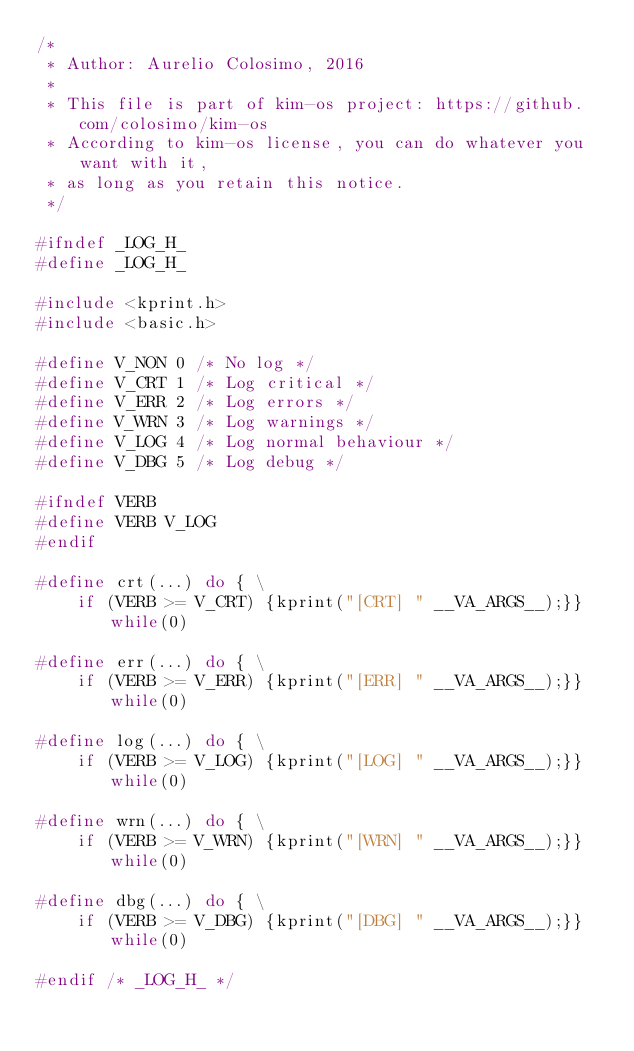<code> <loc_0><loc_0><loc_500><loc_500><_C_>/*
 * Author: Aurelio Colosimo, 2016
 *
 * This file is part of kim-os project: https://github.com/colosimo/kim-os
 * According to kim-os license, you can do whatever you want with it,
 * as long as you retain this notice.
 */

#ifndef _LOG_H_
#define _LOG_H_

#include <kprint.h>
#include <basic.h>

#define V_NON 0 /* No log */
#define V_CRT 1 /* Log critical */
#define V_ERR 2 /* Log errors */
#define V_WRN 3 /* Log warnings */
#define V_LOG 4 /* Log normal behaviour */
#define V_DBG 5 /* Log debug */

#ifndef VERB
#define VERB V_LOG
#endif

#define crt(...) do { \
	if (VERB >= V_CRT) {kprint("[CRT] " __VA_ARGS__);}} while(0)

#define err(...) do { \
	if (VERB >= V_ERR) {kprint("[ERR] " __VA_ARGS__);}} while(0)

#define log(...) do { \
	if (VERB >= V_LOG) {kprint("[LOG] " __VA_ARGS__);}} while(0)

#define wrn(...) do { \
	if (VERB >= V_WRN) {kprint("[WRN] " __VA_ARGS__);}} while(0)

#define dbg(...) do { \
	if (VERB >= V_DBG) {kprint("[DBG] " __VA_ARGS__);}} while(0)

#endif /* _LOG_H_ */
</code> 